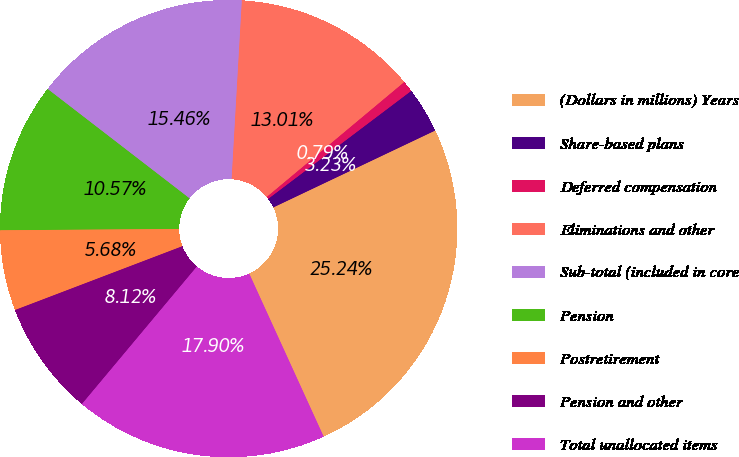Convert chart. <chart><loc_0><loc_0><loc_500><loc_500><pie_chart><fcel>(Dollars in millions) Years<fcel>Share-based plans<fcel>Deferred compensation<fcel>Eliminations and other<fcel>Sub-total (included in core<fcel>Pension<fcel>Postretirement<fcel>Pension and other<fcel>Total unallocated items<nl><fcel>25.24%<fcel>3.23%<fcel>0.79%<fcel>13.01%<fcel>15.46%<fcel>10.57%<fcel>5.68%<fcel>8.12%<fcel>17.9%<nl></chart> 